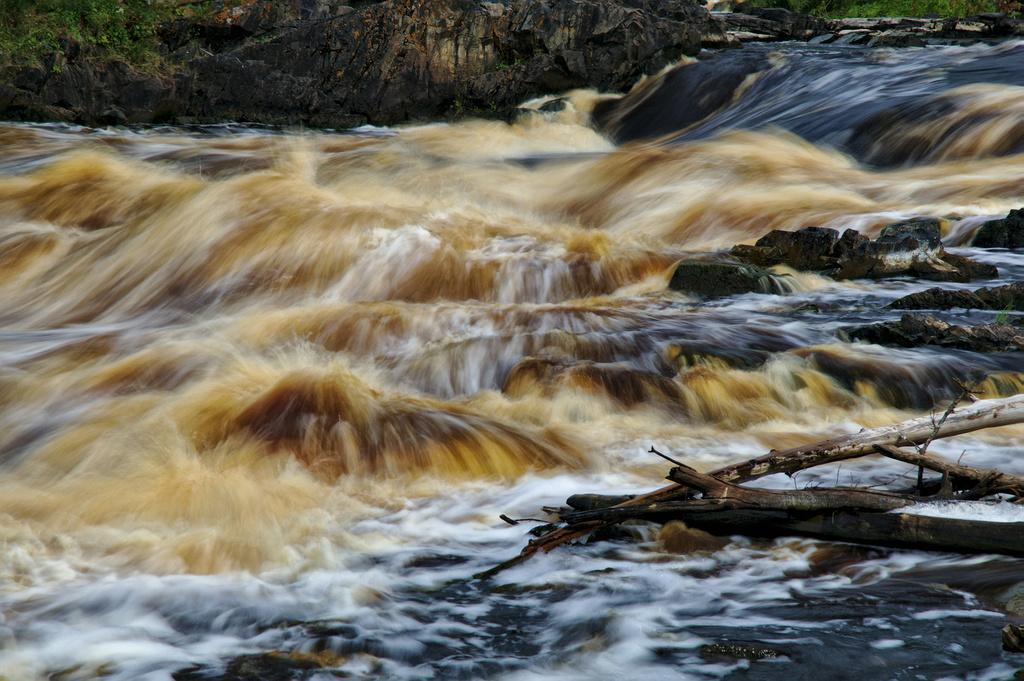What is the primary element visible in the image? There is water in the image. What type of material can be seen in the image? There are wooden branches in the image. What type of living organisms are present in the image? There are plants in the image. What is the opinion of the water in the image? The water in the image does not have an opinion, as it is an inanimate object. 